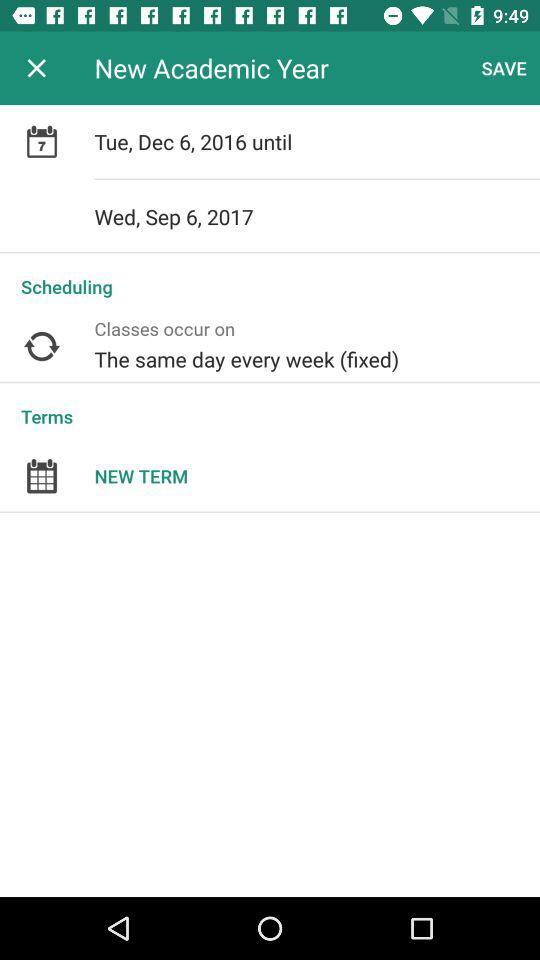What is the day on December 6, 2016 of the New Academic Year? The day is Tuesday. 